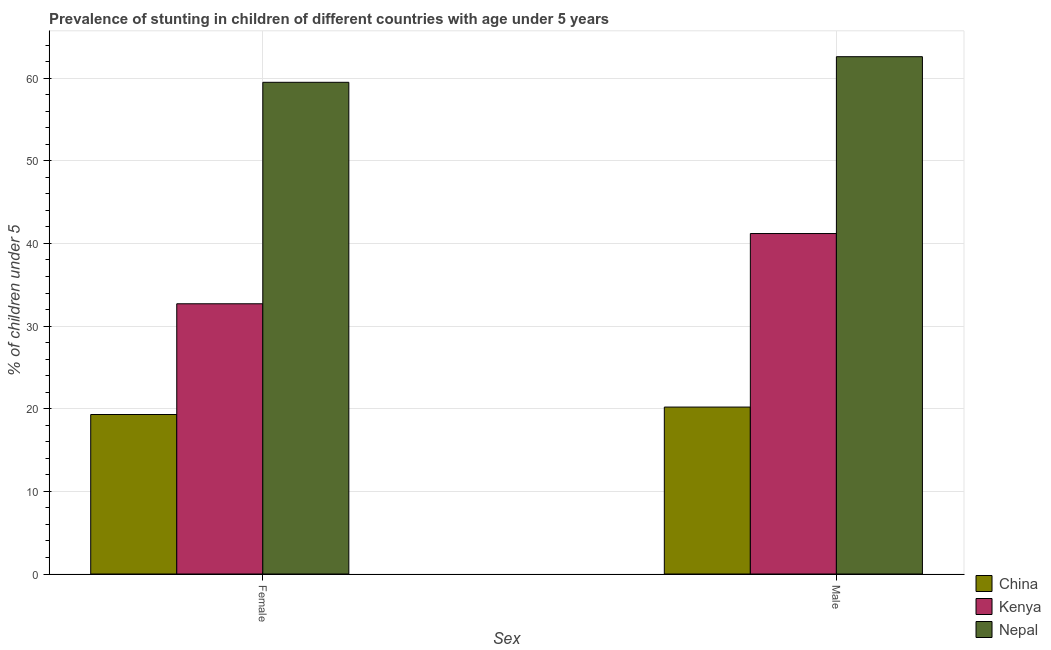How many different coloured bars are there?
Provide a short and direct response. 3. How many bars are there on the 2nd tick from the left?
Your response must be concise. 3. How many bars are there on the 1st tick from the right?
Offer a very short reply. 3. What is the label of the 2nd group of bars from the left?
Provide a short and direct response. Male. What is the percentage of stunted male children in Kenya?
Provide a short and direct response. 41.2. Across all countries, what is the maximum percentage of stunted female children?
Your answer should be compact. 59.5. Across all countries, what is the minimum percentage of stunted male children?
Provide a succinct answer. 20.2. In which country was the percentage of stunted male children maximum?
Offer a terse response. Nepal. In which country was the percentage of stunted male children minimum?
Give a very brief answer. China. What is the total percentage of stunted female children in the graph?
Your answer should be very brief. 111.5. What is the difference between the percentage of stunted male children in China and that in Nepal?
Keep it short and to the point. -42.4. What is the difference between the percentage of stunted male children in Kenya and the percentage of stunted female children in China?
Provide a succinct answer. 21.9. What is the average percentage of stunted male children per country?
Your response must be concise. 41.33. What is the difference between the percentage of stunted female children and percentage of stunted male children in Nepal?
Keep it short and to the point. -3.1. In how many countries, is the percentage of stunted female children greater than 20 %?
Your answer should be very brief. 2. What is the ratio of the percentage of stunted male children in Kenya to that in China?
Offer a terse response. 2.04. What does the 1st bar from the right in Female represents?
Provide a succinct answer. Nepal. Are all the bars in the graph horizontal?
Offer a terse response. No. How many countries are there in the graph?
Give a very brief answer. 3. What is the difference between two consecutive major ticks on the Y-axis?
Provide a short and direct response. 10. Are the values on the major ticks of Y-axis written in scientific E-notation?
Keep it short and to the point. No. How many legend labels are there?
Offer a very short reply. 3. What is the title of the graph?
Provide a short and direct response. Prevalence of stunting in children of different countries with age under 5 years. Does "Heavily indebted poor countries" appear as one of the legend labels in the graph?
Offer a terse response. No. What is the label or title of the X-axis?
Give a very brief answer. Sex. What is the label or title of the Y-axis?
Keep it short and to the point.  % of children under 5. What is the  % of children under 5 of China in Female?
Your answer should be very brief. 19.3. What is the  % of children under 5 of Kenya in Female?
Keep it short and to the point. 32.7. What is the  % of children under 5 in Nepal in Female?
Make the answer very short. 59.5. What is the  % of children under 5 in China in Male?
Offer a terse response. 20.2. What is the  % of children under 5 of Kenya in Male?
Make the answer very short. 41.2. What is the  % of children under 5 of Nepal in Male?
Keep it short and to the point. 62.6. Across all Sex, what is the maximum  % of children under 5 in China?
Provide a short and direct response. 20.2. Across all Sex, what is the maximum  % of children under 5 of Kenya?
Your response must be concise. 41.2. Across all Sex, what is the maximum  % of children under 5 of Nepal?
Offer a very short reply. 62.6. Across all Sex, what is the minimum  % of children under 5 of China?
Offer a terse response. 19.3. Across all Sex, what is the minimum  % of children under 5 of Kenya?
Offer a terse response. 32.7. Across all Sex, what is the minimum  % of children under 5 of Nepal?
Keep it short and to the point. 59.5. What is the total  % of children under 5 in China in the graph?
Make the answer very short. 39.5. What is the total  % of children under 5 in Kenya in the graph?
Offer a very short reply. 73.9. What is the total  % of children under 5 of Nepal in the graph?
Your response must be concise. 122.1. What is the difference between the  % of children under 5 in Nepal in Female and that in Male?
Your answer should be very brief. -3.1. What is the difference between the  % of children under 5 of China in Female and the  % of children under 5 of Kenya in Male?
Your answer should be very brief. -21.9. What is the difference between the  % of children under 5 in China in Female and the  % of children under 5 in Nepal in Male?
Provide a succinct answer. -43.3. What is the difference between the  % of children under 5 in Kenya in Female and the  % of children under 5 in Nepal in Male?
Your answer should be very brief. -29.9. What is the average  % of children under 5 in China per Sex?
Give a very brief answer. 19.75. What is the average  % of children under 5 of Kenya per Sex?
Ensure brevity in your answer.  36.95. What is the average  % of children under 5 of Nepal per Sex?
Make the answer very short. 61.05. What is the difference between the  % of children under 5 in China and  % of children under 5 in Nepal in Female?
Keep it short and to the point. -40.2. What is the difference between the  % of children under 5 of Kenya and  % of children under 5 of Nepal in Female?
Keep it short and to the point. -26.8. What is the difference between the  % of children under 5 in China and  % of children under 5 in Nepal in Male?
Ensure brevity in your answer.  -42.4. What is the difference between the  % of children under 5 in Kenya and  % of children under 5 in Nepal in Male?
Keep it short and to the point. -21.4. What is the ratio of the  % of children under 5 of China in Female to that in Male?
Offer a terse response. 0.96. What is the ratio of the  % of children under 5 of Kenya in Female to that in Male?
Your answer should be compact. 0.79. What is the ratio of the  % of children under 5 of Nepal in Female to that in Male?
Your answer should be very brief. 0.95. What is the difference between the highest and the second highest  % of children under 5 of China?
Make the answer very short. 0.9. What is the difference between the highest and the second highest  % of children under 5 in Nepal?
Your response must be concise. 3.1. What is the difference between the highest and the lowest  % of children under 5 in China?
Give a very brief answer. 0.9. What is the difference between the highest and the lowest  % of children under 5 of Kenya?
Provide a succinct answer. 8.5. What is the difference between the highest and the lowest  % of children under 5 in Nepal?
Give a very brief answer. 3.1. 